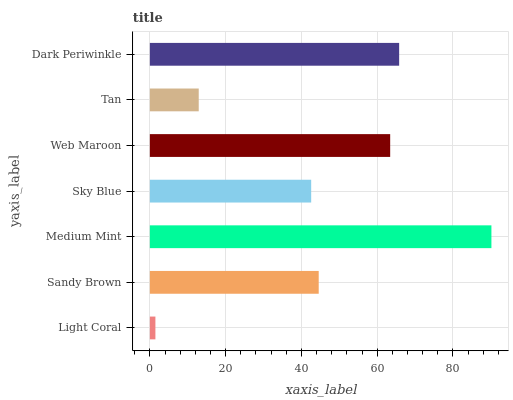Is Light Coral the minimum?
Answer yes or no. Yes. Is Medium Mint the maximum?
Answer yes or no. Yes. Is Sandy Brown the minimum?
Answer yes or no. No. Is Sandy Brown the maximum?
Answer yes or no. No. Is Sandy Brown greater than Light Coral?
Answer yes or no. Yes. Is Light Coral less than Sandy Brown?
Answer yes or no. Yes. Is Light Coral greater than Sandy Brown?
Answer yes or no. No. Is Sandy Brown less than Light Coral?
Answer yes or no. No. Is Sandy Brown the high median?
Answer yes or no. Yes. Is Sandy Brown the low median?
Answer yes or no. Yes. Is Sky Blue the high median?
Answer yes or no. No. Is Medium Mint the low median?
Answer yes or no. No. 